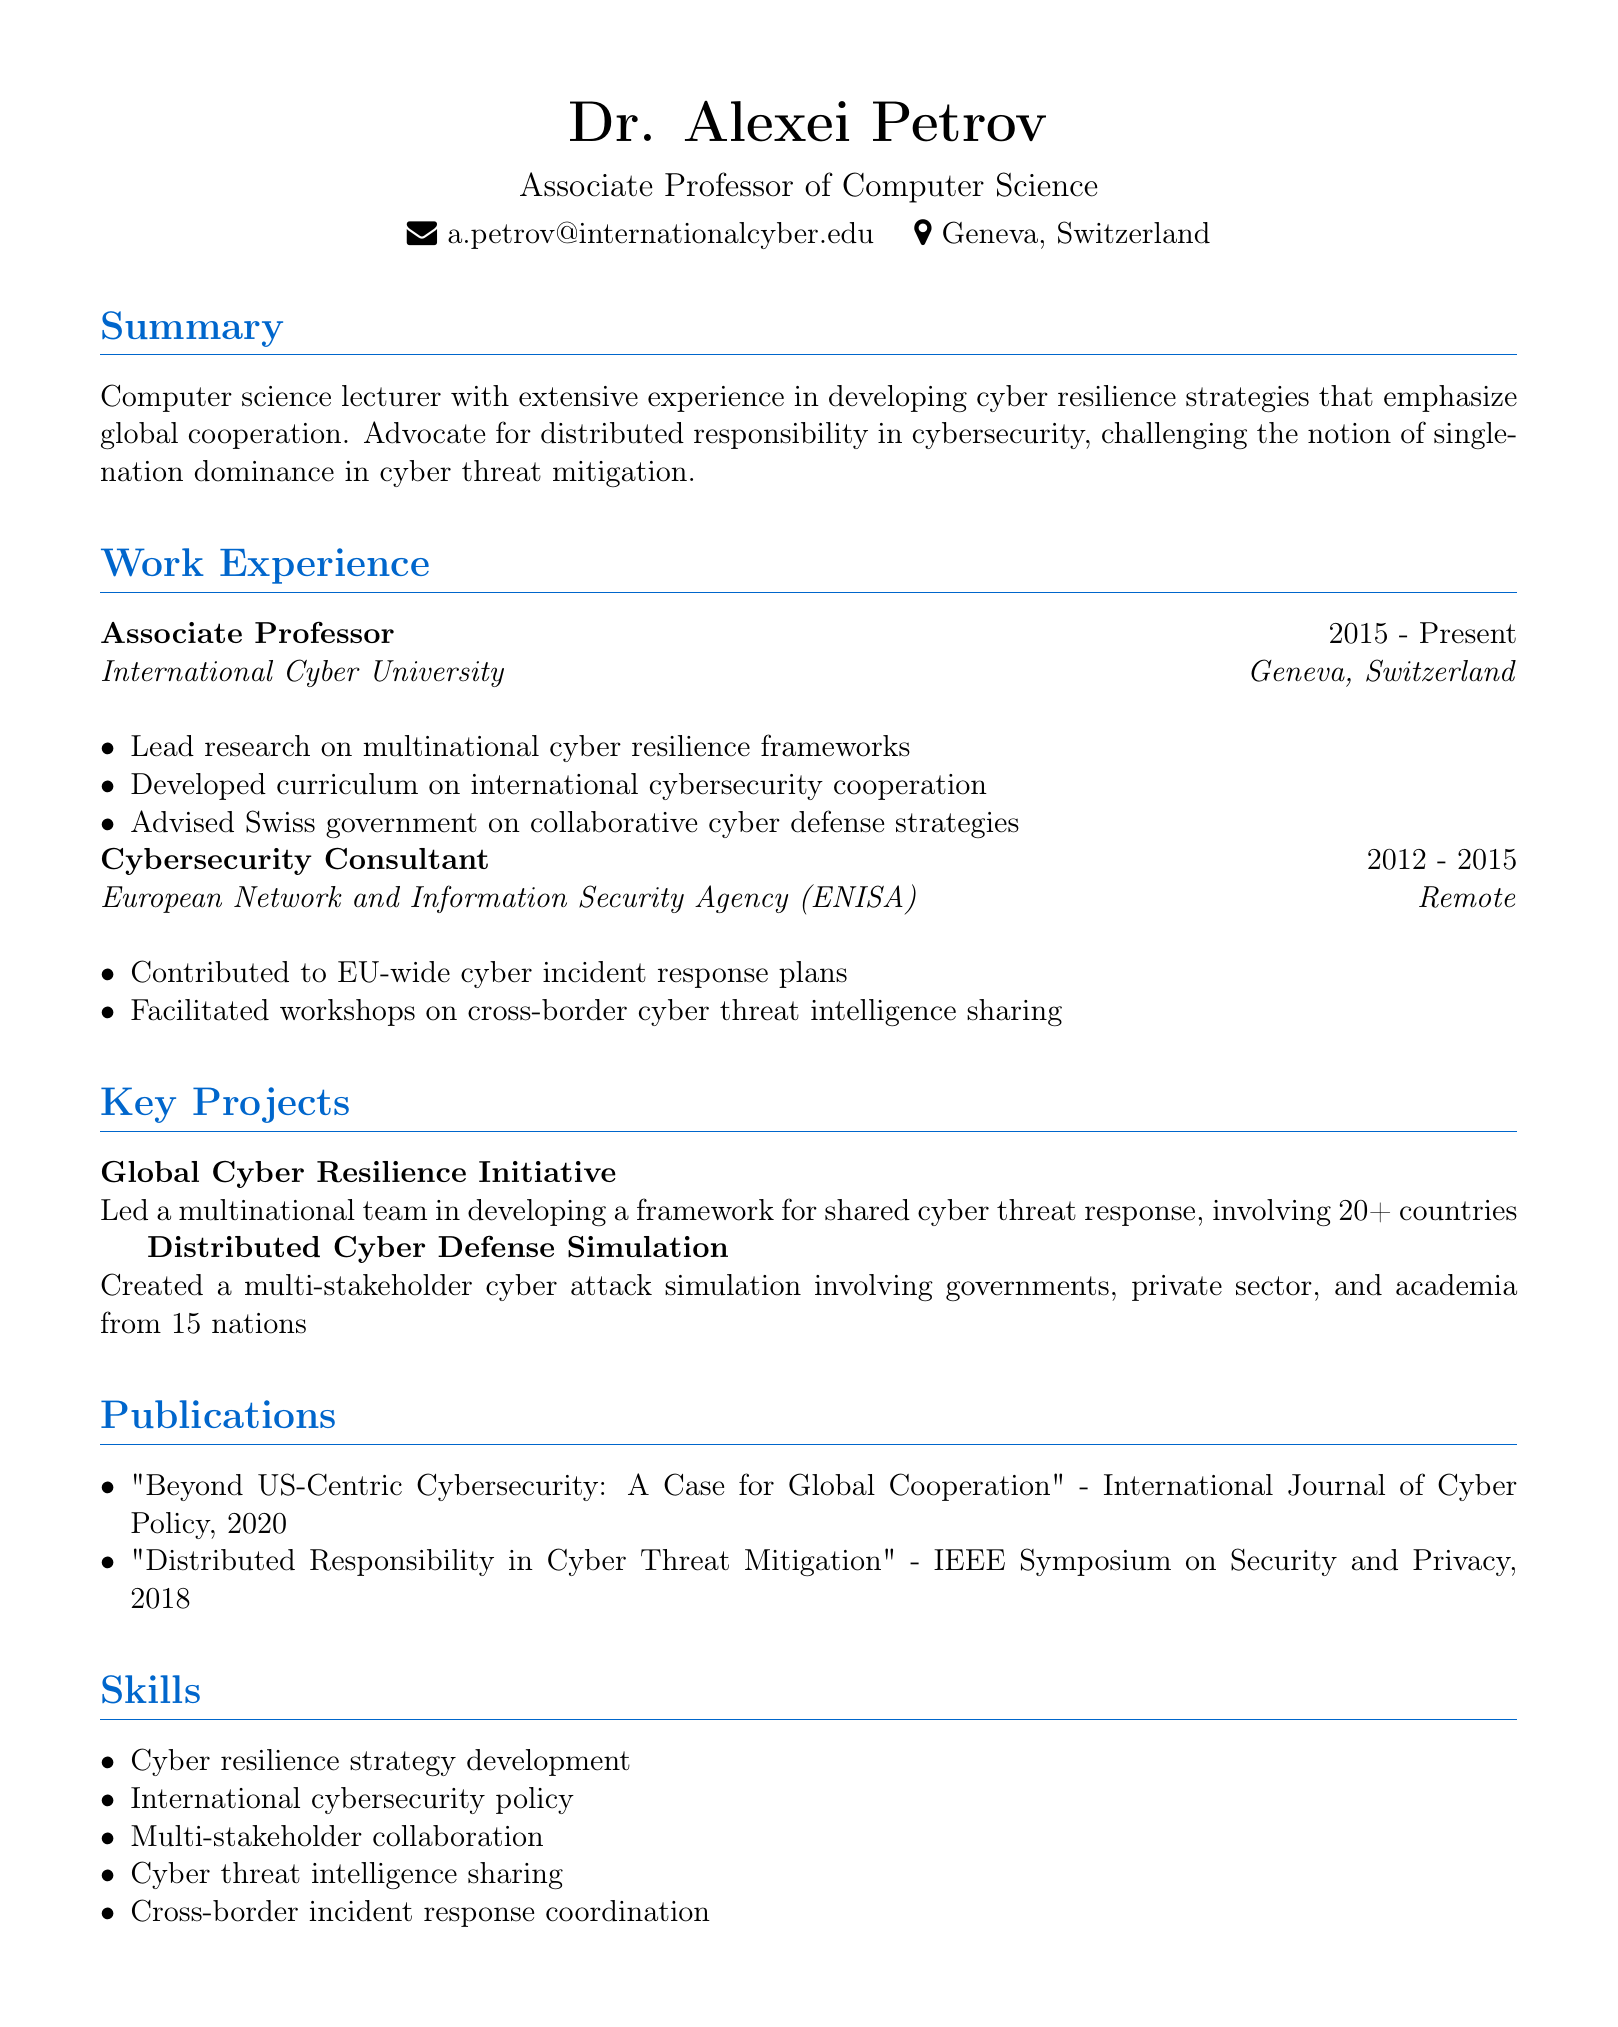What is the name of the lecturer? The lecturer's name is found in the personal information section of the document.
Answer: Dr. Alexei Petrov How long has Dr. Alexei Petrov been an Associate Professor? The duration of employment is stated in the work experience section.
Answer: 2015 - Present What is the title of the publication from 2020? This title is listed under the publications section of the document.
Answer: Beyond US-Centric Cybersecurity: A Case for Global Cooperation Which organization did Dr. Alexei Petrov advise on collaborative cyber defense strategies? This organization is mentioned in the work experience section related to responsibilities.
Answer: Swiss government What was a key focus of the Global Cyber Resilience Initiative? The description of the project provides insight into its main objective.
Answer: Shared cyber threat response How many nations were involved in the Distributed Cyber Defense Simulation? The number is directly stated in the project description.
Answer: 15 nations What is one of the skills listed in the resume? Skills are enumerated in a specific section of the document.
Answer: Multi-stakeholder collaboration How many projects are listed under key projects? The number is determined by counting the projects in the key projects section.
Answer: 2 